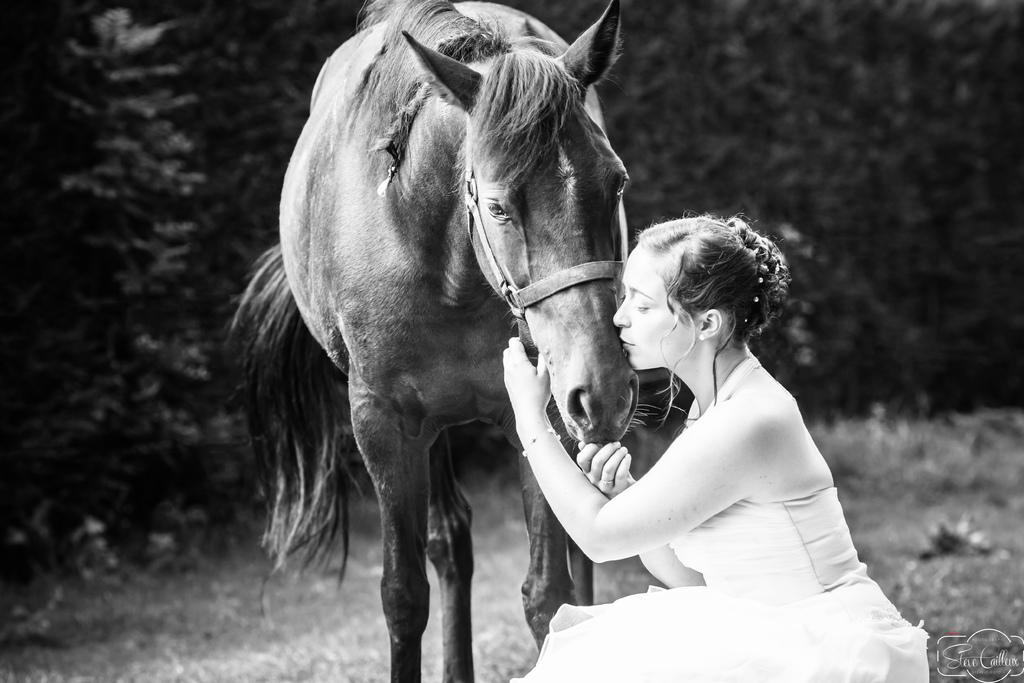Who is present in the image? There is a woman in the image. What is the woman doing in the image? The woman is kissing a horse. What type of stamp can be seen on the horse's back in the image? There is no stamp visible on the horse's back in the image. How much profit does the woman make from the horse in the image? There is no information about profit in the image, as it only shows the woman kissing a horse. 